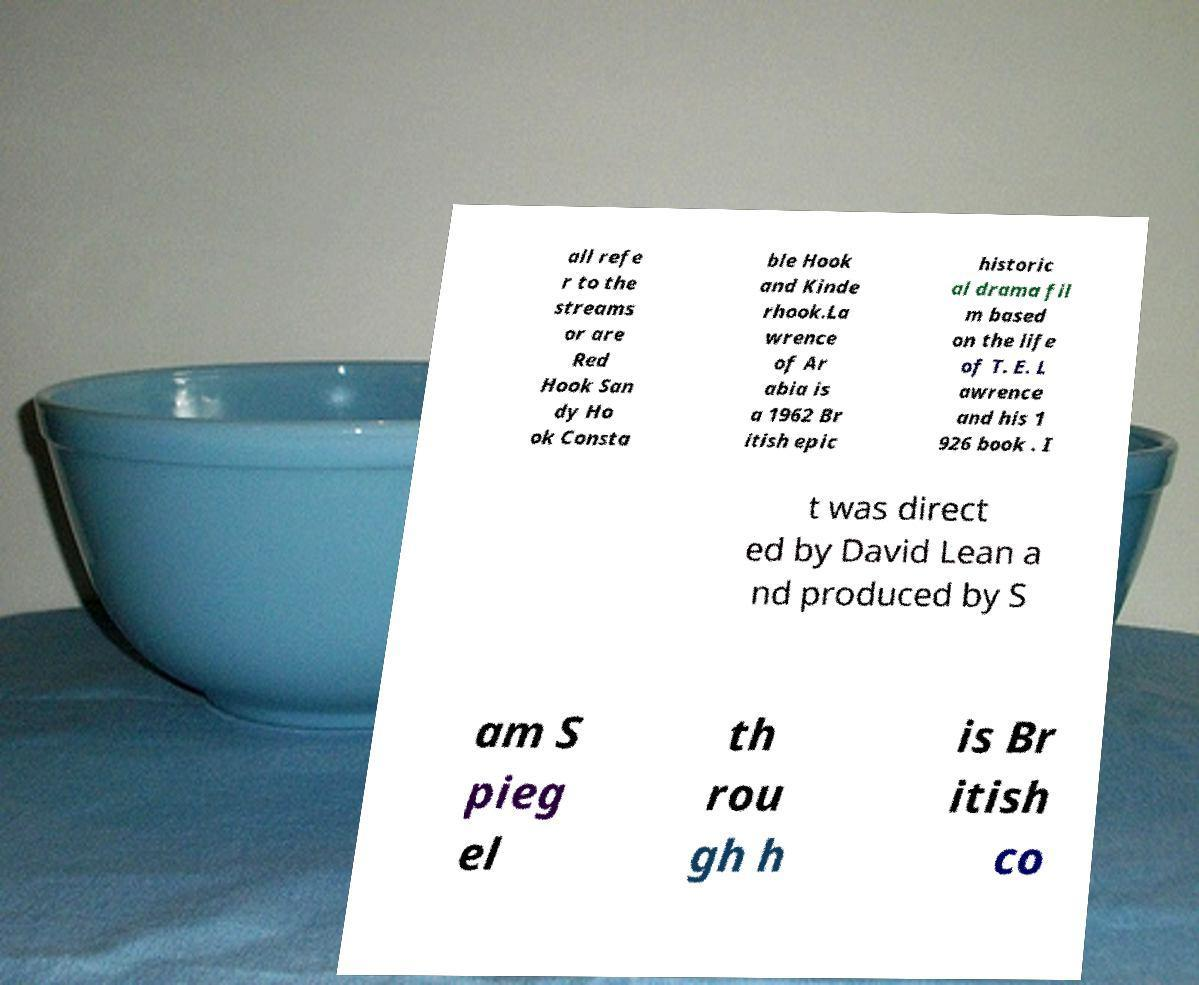There's text embedded in this image that I need extracted. Can you transcribe it verbatim? all refe r to the streams or are Red Hook San dy Ho ok Consta ble Hook and Kinde rhook.La wrence of Ar abia is a 1962 Br itish epic historic al drama fil m based on the life of T. E. L awrence and his 1 926 book . I t was direct ed by David Lean a nd produced by S am S pieg el th rou gh h is Br itish co 